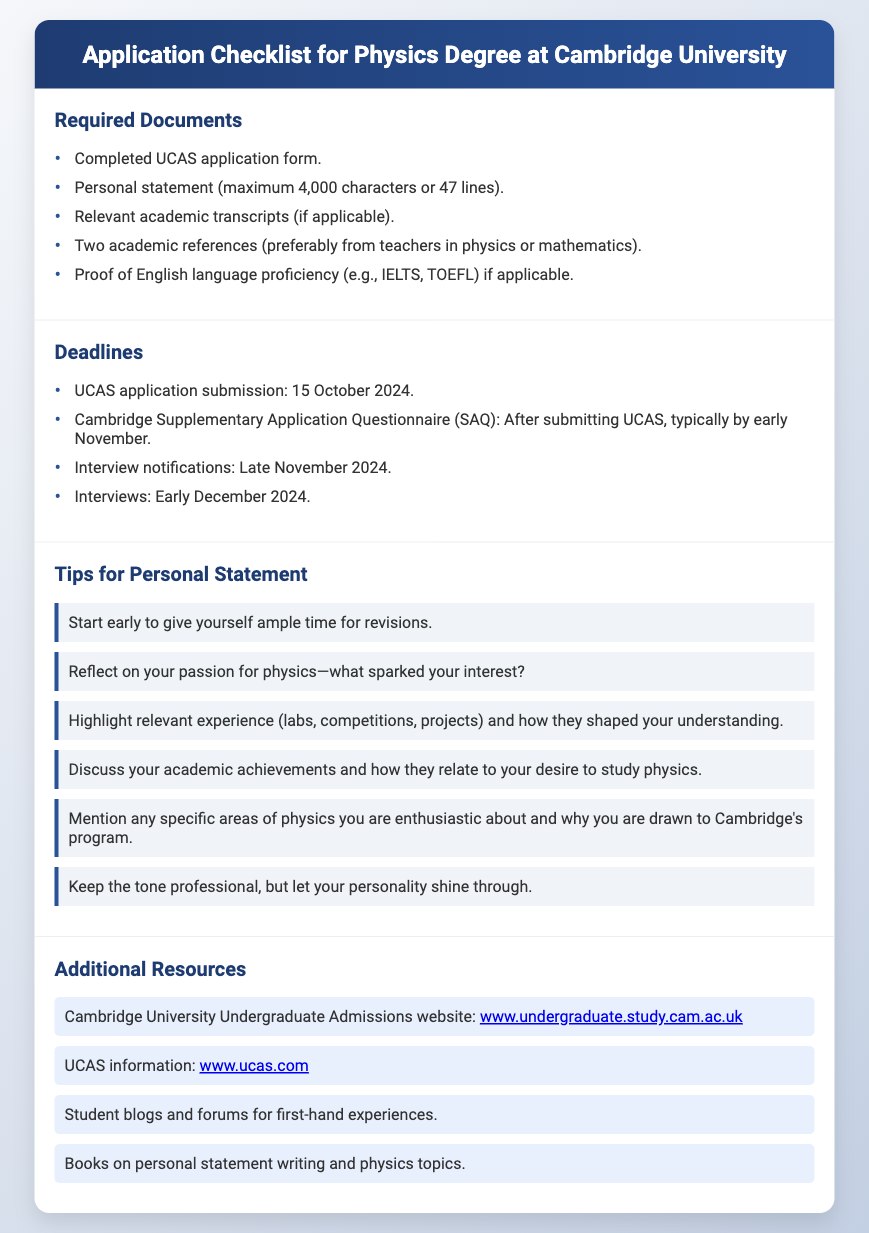What is the deadline for UCAS application submission? The deadline for UCAS application submission is explicitly stated in the document, which is 15 October 2024.
Answer: 15 October 2024 How many academic references are required? The document specifies that two academic references are required, preferably from teachers in physics or mathematics.
Answer: Two What is the maximum character limit for the personal statement? The maximum character limit for the personal statement is mentioned as 4,000 characters or 47 lines.
Answer: 4,000 characters When are the interviews scheduled? The document indicates that interviews are scheduled for early December 2024.
Answer: Early December 2024 What should you reflect on in your personal statement? The document suggests reflecting on what sparked your interest in physics as a key component of the personal statement.
Answer: Your passion for physics What is one reason to start writing your personal statement early? The document points out starting early gives ample time for revisions, which is crucial for a strong personal statement.
Answer: Ample time for revisions Where can you find additional resources for the application? The document mentions several resources, including the Cambridge University Undergraduate Admissions website and UCAS information, as good places for additional information.
Answer: Cambridge University Undergraduate Admissions website What area of physics should you mention in your personal statement? The document recommends mentioning specific areas of physics you are enthusiastic about, connecting it to your desire to study at Cambridge.
Answer: Specific areas of physics What type of tone is suggested for the personal statement? The document advises keeping a professional tone while letting your personality shine through in the personal statement.
Answer: Professional tone 